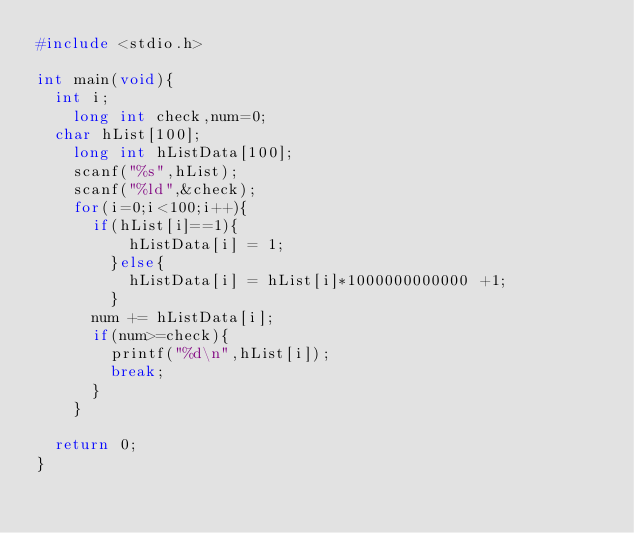<code> <loc_0><loc_0><loc_500><loc_500><_C_>#include <stdio.h>

int main(void){
  int i;
  	long int check,num=0;
	char hList[100];
  	long int hListData[100];
  	scanf("%s",hList);
  	scanf("%ld",&check);
  	for(i=0;i<100;i++){
    	if(hList[i]==1){
          hListData[i] = 1;
        }else{
       		hListData[i] = hList[i]*1000000000000 +1;
        }
      num += hListData[i];
      if(num>=check){
      	printf("%d\n",hList[i]);
        break;
      }
    }

	return 0;
}
</code> 